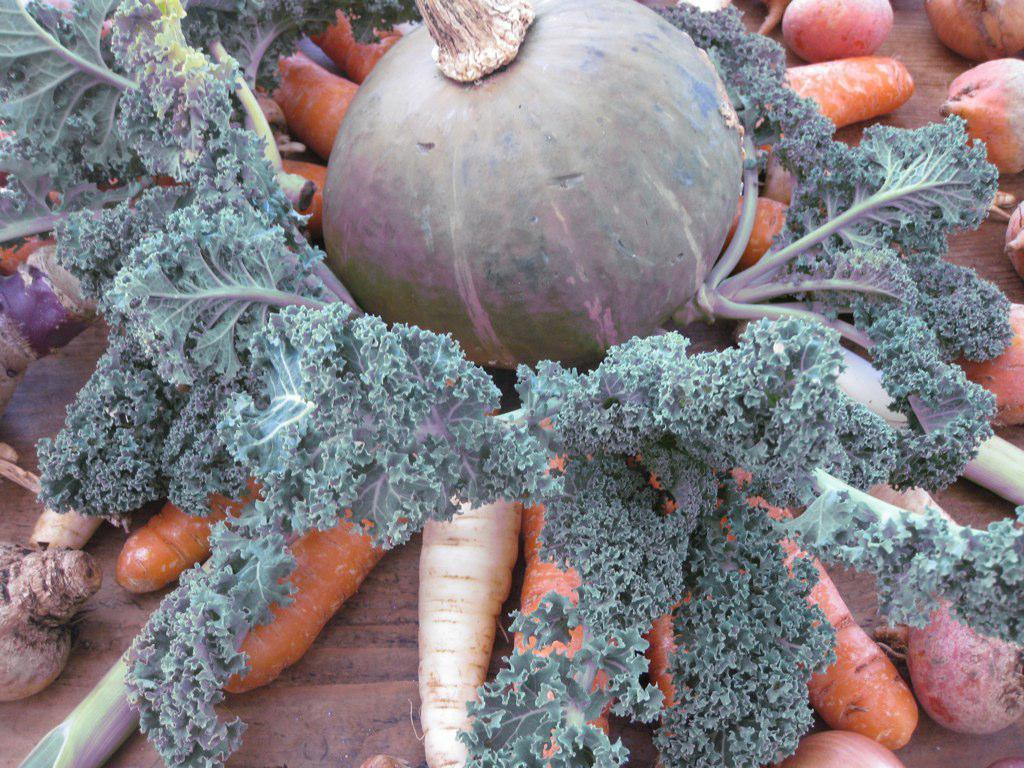What type of food can be seen on the table in the image? There are vegetables on the table in the image. Can you name some specific vegetables that are present on the table? Carrots, radish, pumpkin, turnip, and broccoli are present on the table. What type of memory is stored in the goldfish on the table in the image? There is no goldfish present in the image; it only features vegetables on the table. 